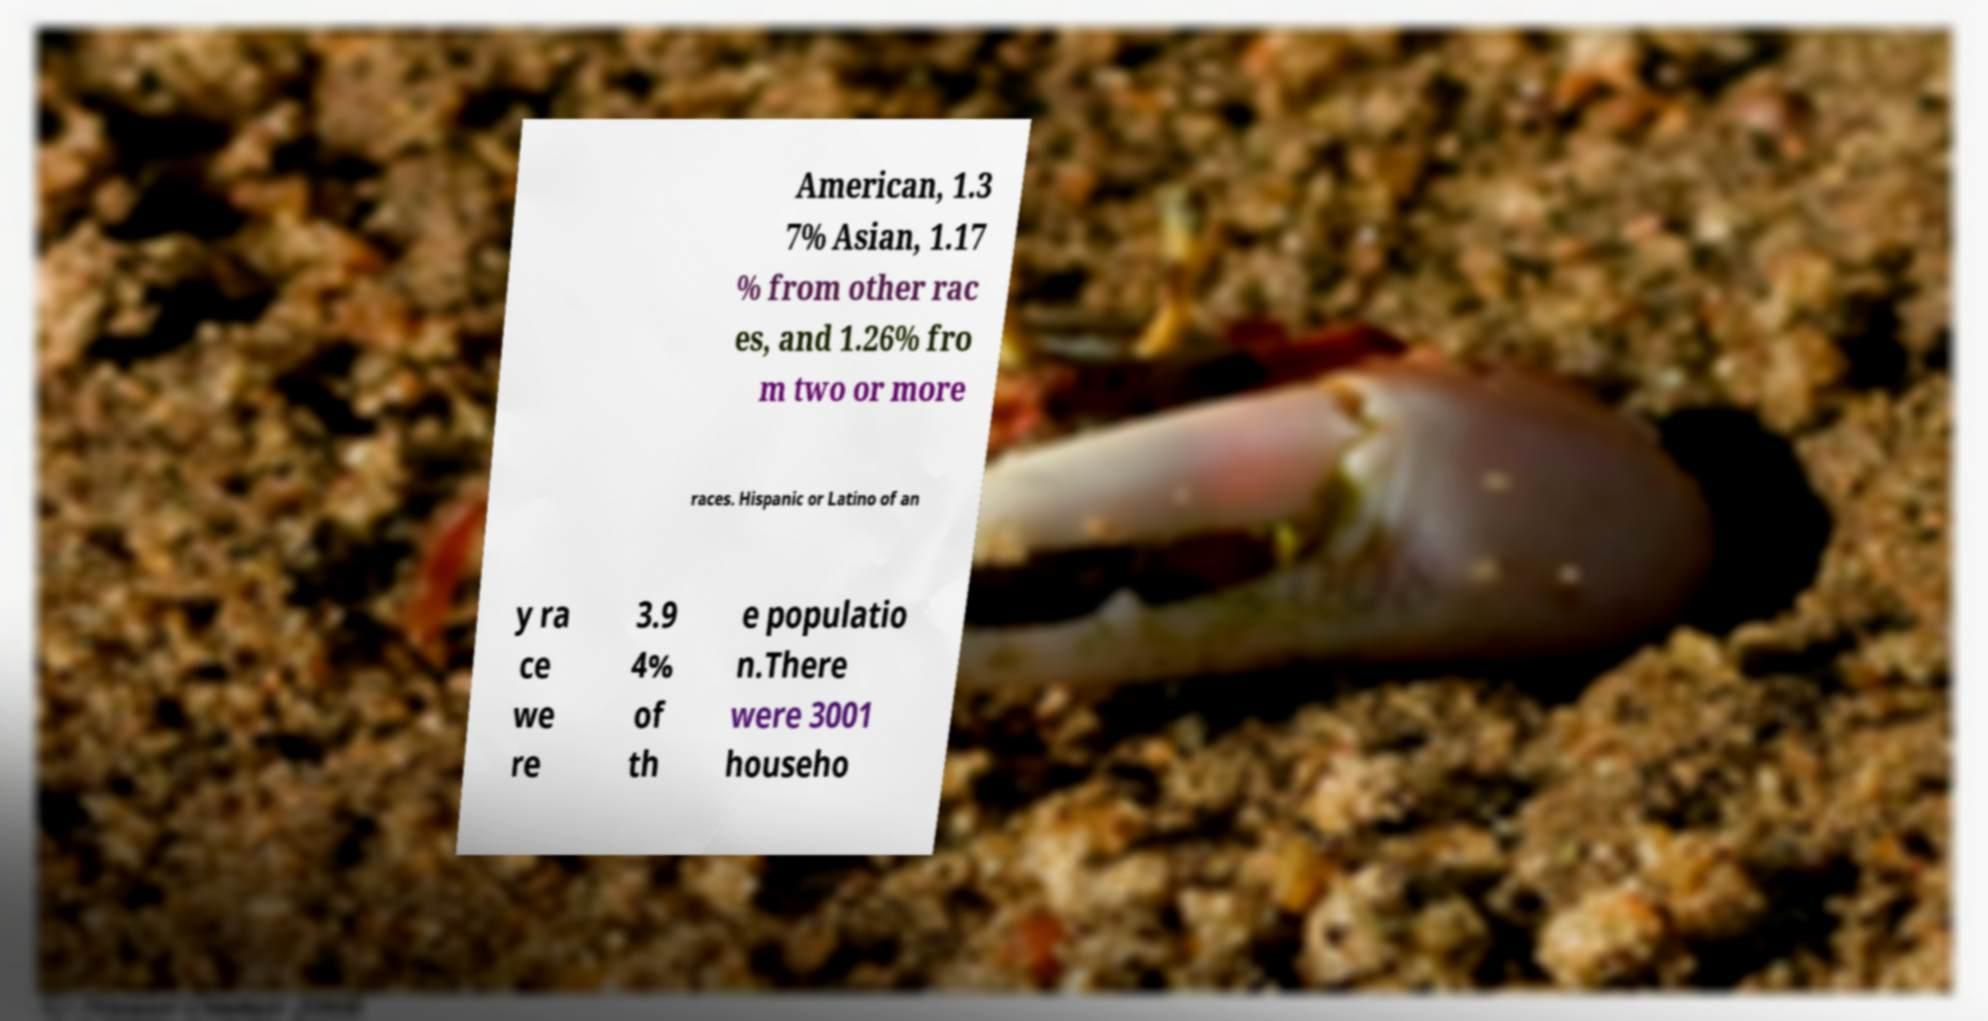There's text embedded in this image that I need extracted. Can you transcribe it verbatim? American, 1.3 7% Asian, 1.17 % from other rac es, and 1.26% fro m two or more races. Hispanic or Latino of an y ra ce we re 3.9 4% of th e populatio n.There were 3001 househo 